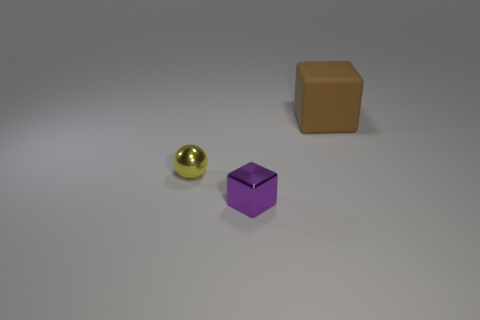What shape is the object that is to the right of the yellow shiny thing and in front of the brown thing?
Keep it short and to the point. Cube. Is there any other thing that is the same size as the brown cube?
Keep it short and to the point. No. There is a metal object that is the same shape as the big rubber thing; what is its color?
Keep it short and to the point. Purple. There is a small metallic object that is in front of the small object that is behind the tiny purple metallic object; what number of purple cubes are to the left of it?
Ensure brevity in your answer.  0. Are there any other things that have the same material as the large brown cube?
Make the answer very short. No. Are there fewer large brown rubber cubes behind the small yellow object than objects?
Ensure brevity in your answer.  Yes. The purple shiny thing that is the same shape as the big brown matte thing is what size?
Give a very brief answer. Small. How many cubes are made of the same material as the tiny purple thing?
Offer a terse response. 0. Is the cube that is to the left of the rubber object made of the same material as the large object?
Your answer should be compact. No. Is the number of brown things on the left side of the purple metallic cube the same as the number of green cylinders?
Your response must be concise. Yes. 